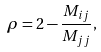<formula> <loc_0><loc_0><loc_500><loc_500>\rho = 2 - \frac { M _ { i j } } { M _ { j j } } ,</formula> 